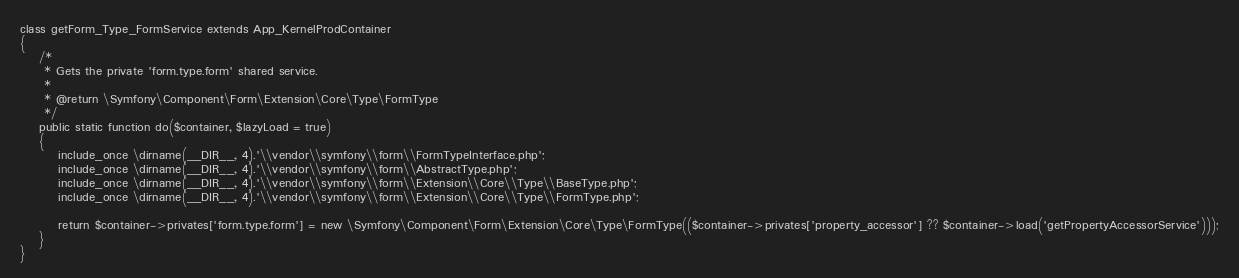<code> <loc_0><loc_0><loc_500><loc_500><_PHP_>class getForm_Type_FormService extends App_KernelProdContainer
{
    /*
     * Gets the private 'form.type.form' shared service.
     *
     * @return \Symfony\Component\Form\Extension\Core\Type\FormType
     */
    public static function do($container, $lazyLoad = true)
    {
        include_once \dirname(__DIR__, 4).'\\vendor\\symfony\\form\\FormTypeInterface.php';
        include_once \dirname(__DIR__, 4).'\\vendor\\symfony\\form\\AbstractType.php';
        include_once \dirname(__DIR__, 4).'\\vendor\\symfony\\form\\Extension\\Core\\Type\\BaseType.php';
        include_once \dirname(__DIR__, 4).'\\vendor\\symfony\\form\\Extension\\Core\\Type\\FormType.php';

        return $container->privates['form.type.form'] = new \Symfony\Component\Form\Extension\Core\Type\FormType(($container->privates['property_accessor'] ?? $container->load('getPropertyAccessorService')));
    }
}
</code> 